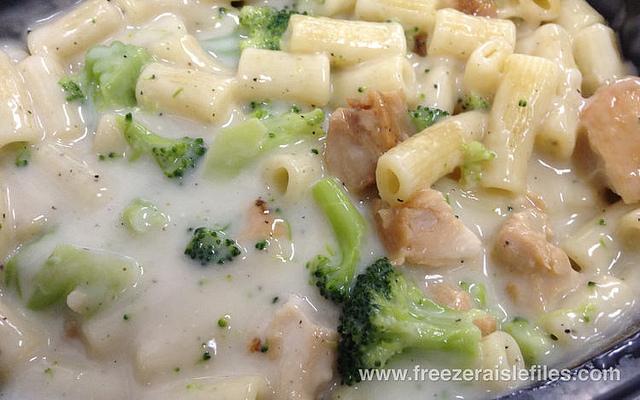Is there broccoli?
Give a very brief answer. Yes. Is this food?
Be succinct. Yes. What is the common name for the shape of this pasta?
Short answer required. Round. 